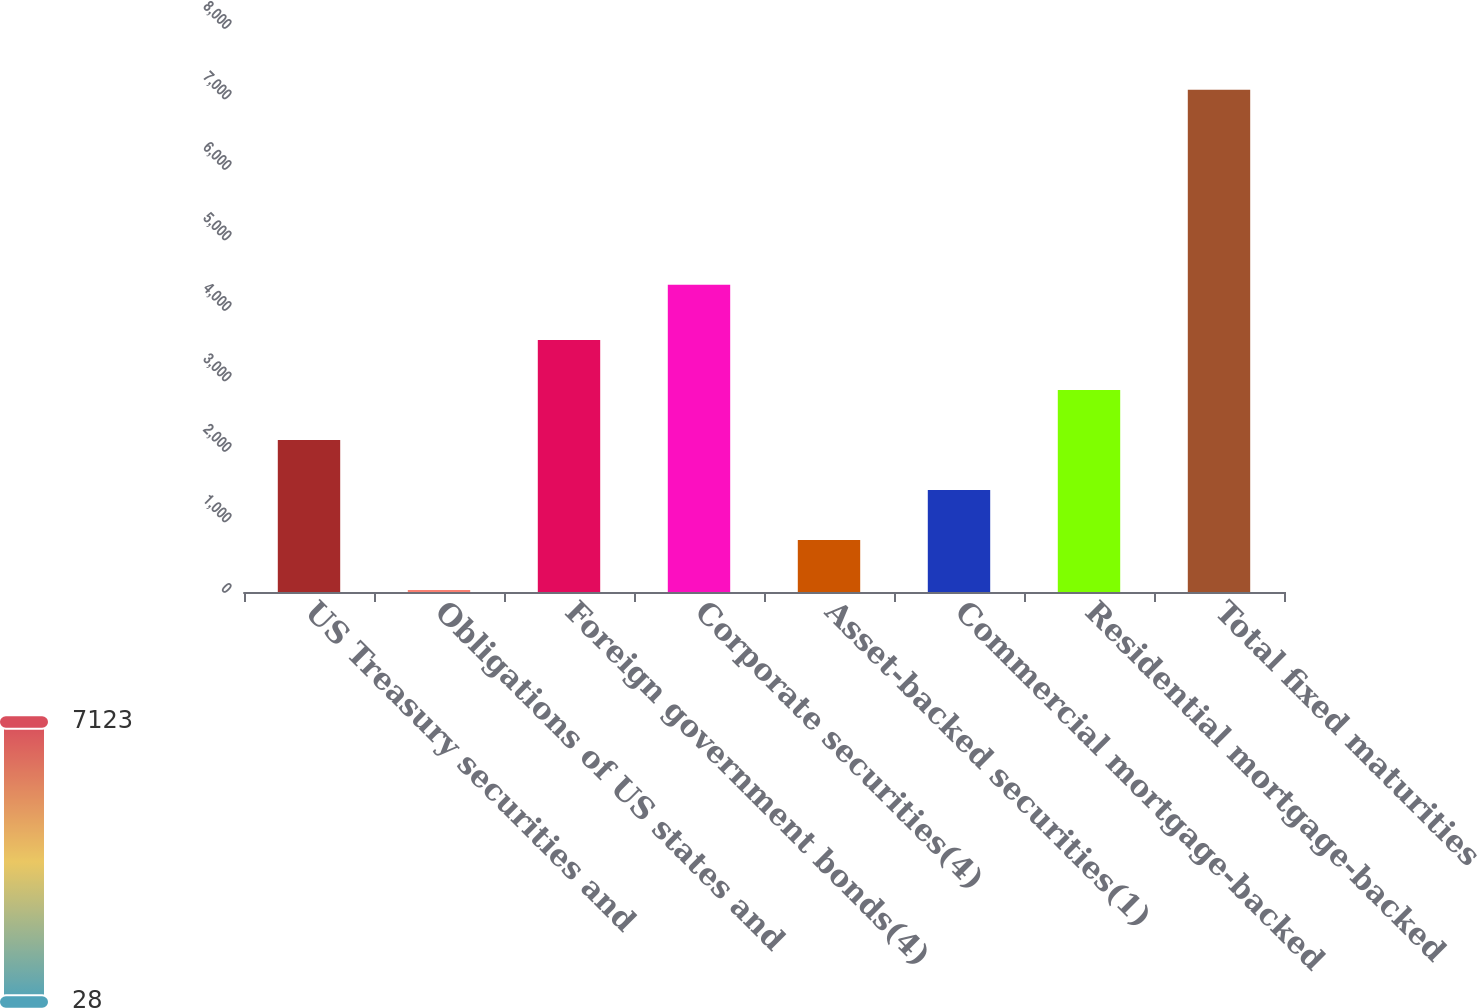Convert chart. <chart><loc_0><loc_0><loc_500><loc_500><bar_chart><fcel>US Treasury securities and<fcel>Obligations of US states and<fcel>Foreign government bonds(4)<fcel>Corporate securities(4)<fcel>Asset-backed securities(1)<fcel>Commercial mortgage-backed<fcel>Residential mortgage-backed<fcel>Total fixed maturities<nl><fcel>2156.5<fcel>28<fcel>3575.5<fcel>4357<fcel>737.5<fcel>1447<fcel>2866<fcel>7123<nl></chart> 